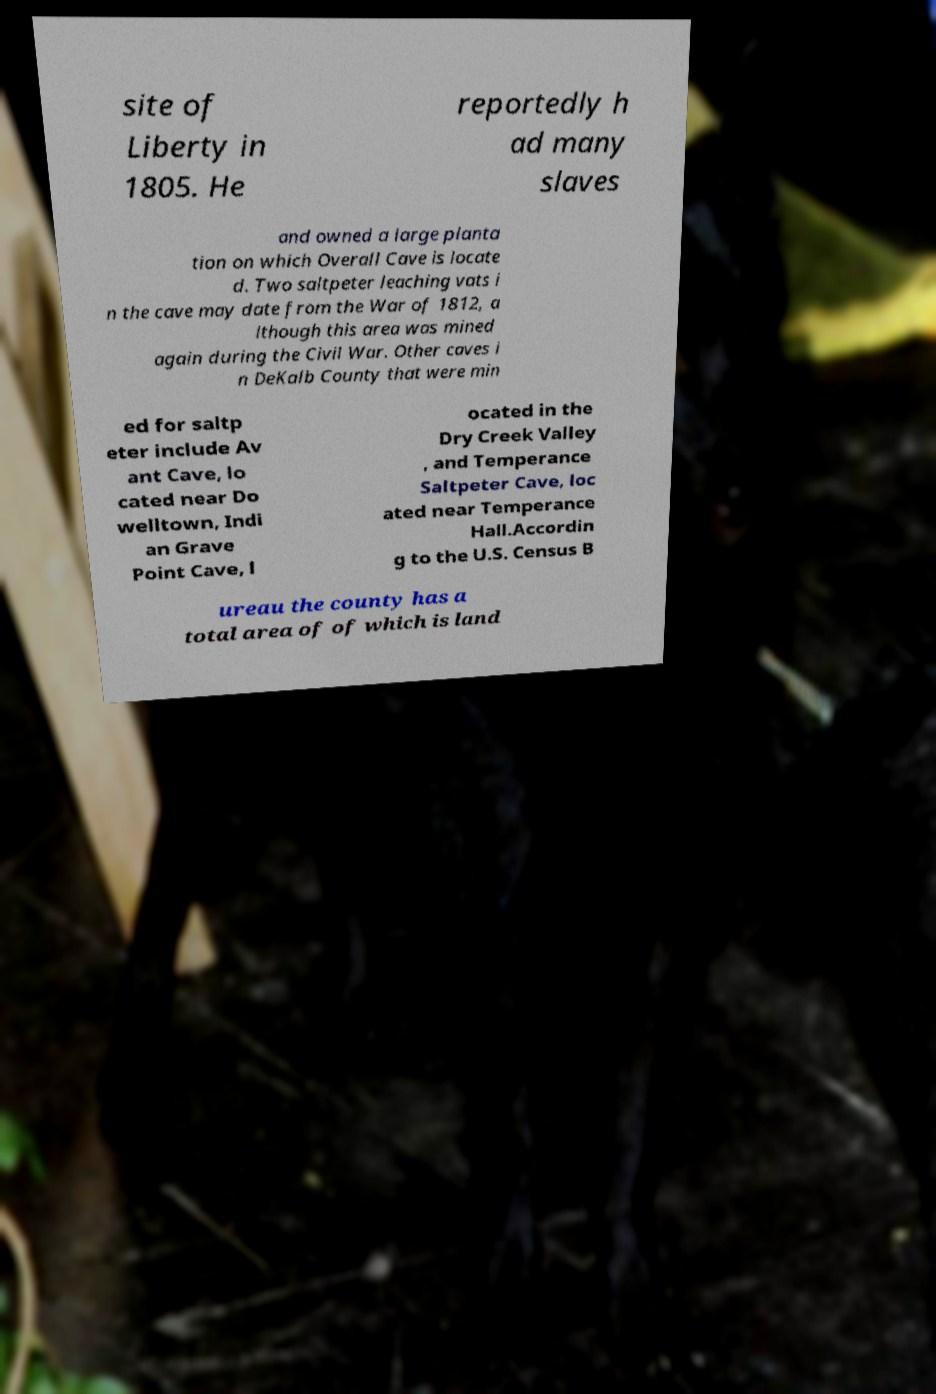Can you read and provide the text displayed in the image?This photo seems to have some interesting text. Can you extract and type it out for me? site of Liberty in 1805. He reportedly h ad many slaves and owned a large planta tion on which Overall Cave is locate d. Two saltpeter leaching vats i n the cave may date from the War of 1812, a lthough this area was mined again during the Civil War. Other caves i n DeKalb County that were min ed for saltp eter include Av ant Cave, lo cated near Do welltown, Indi an Grave Point Cave, l ocated in the Dry Creek Valley , and Temperance Saltpeter Cave, loc ated near Temperance Hall.Accordin g to the U.S. Census B ureau the county has a total area of of which is land 